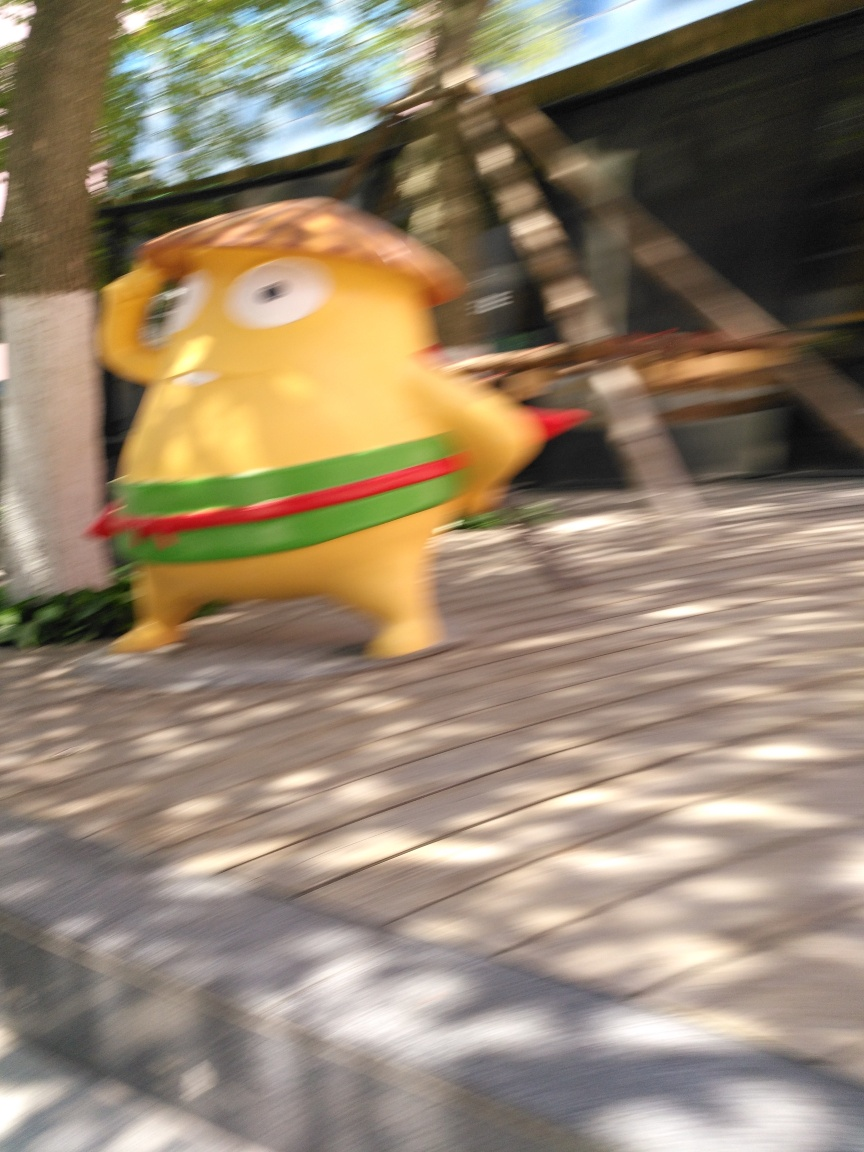Is the lighting strong in this image? The photograph features a prominent play of light and shadow, suggesting strong illumination paired with the blur caused by motion, giving the impression of strong lighting conditions when the image was captured. 